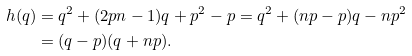Convert formula to latex. <formula><loc_0><loc_0><loc_500><loc_500>h ( q ) & = q ^ { 2 } + ( 2 p n - 1 ) q + p ^ { 2 } - p = q ^ { 2 } + ( n p - p ) q - n p ^ { 2 } \\ & = ( q - p ) ( q + n p ) .</formula> 